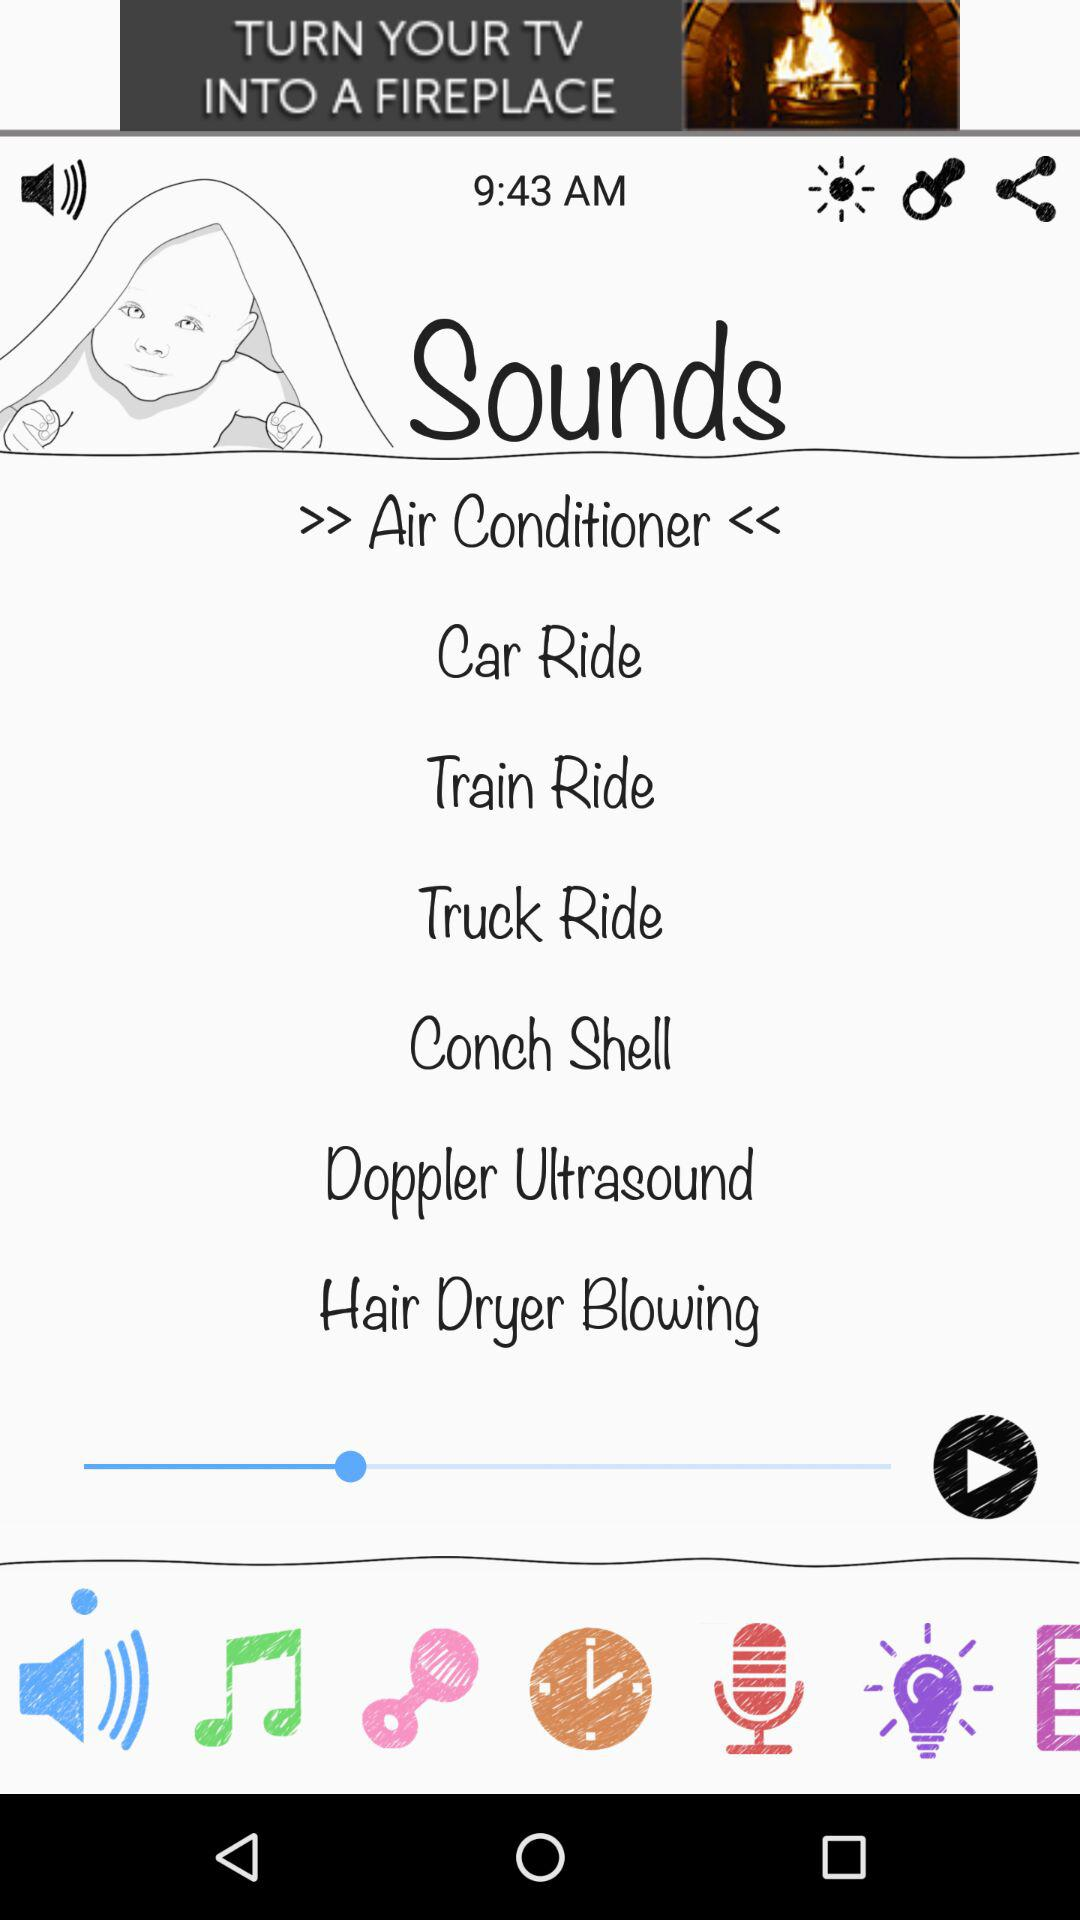What is the mentioned time? The mentioned time is 9:43 AM. 